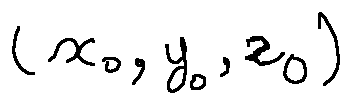<formula> <loc_0><loc_0><loc_500><loc_500>( x _ { 0 } , y _ { 0 } , z _ { 0 } )</formula> 